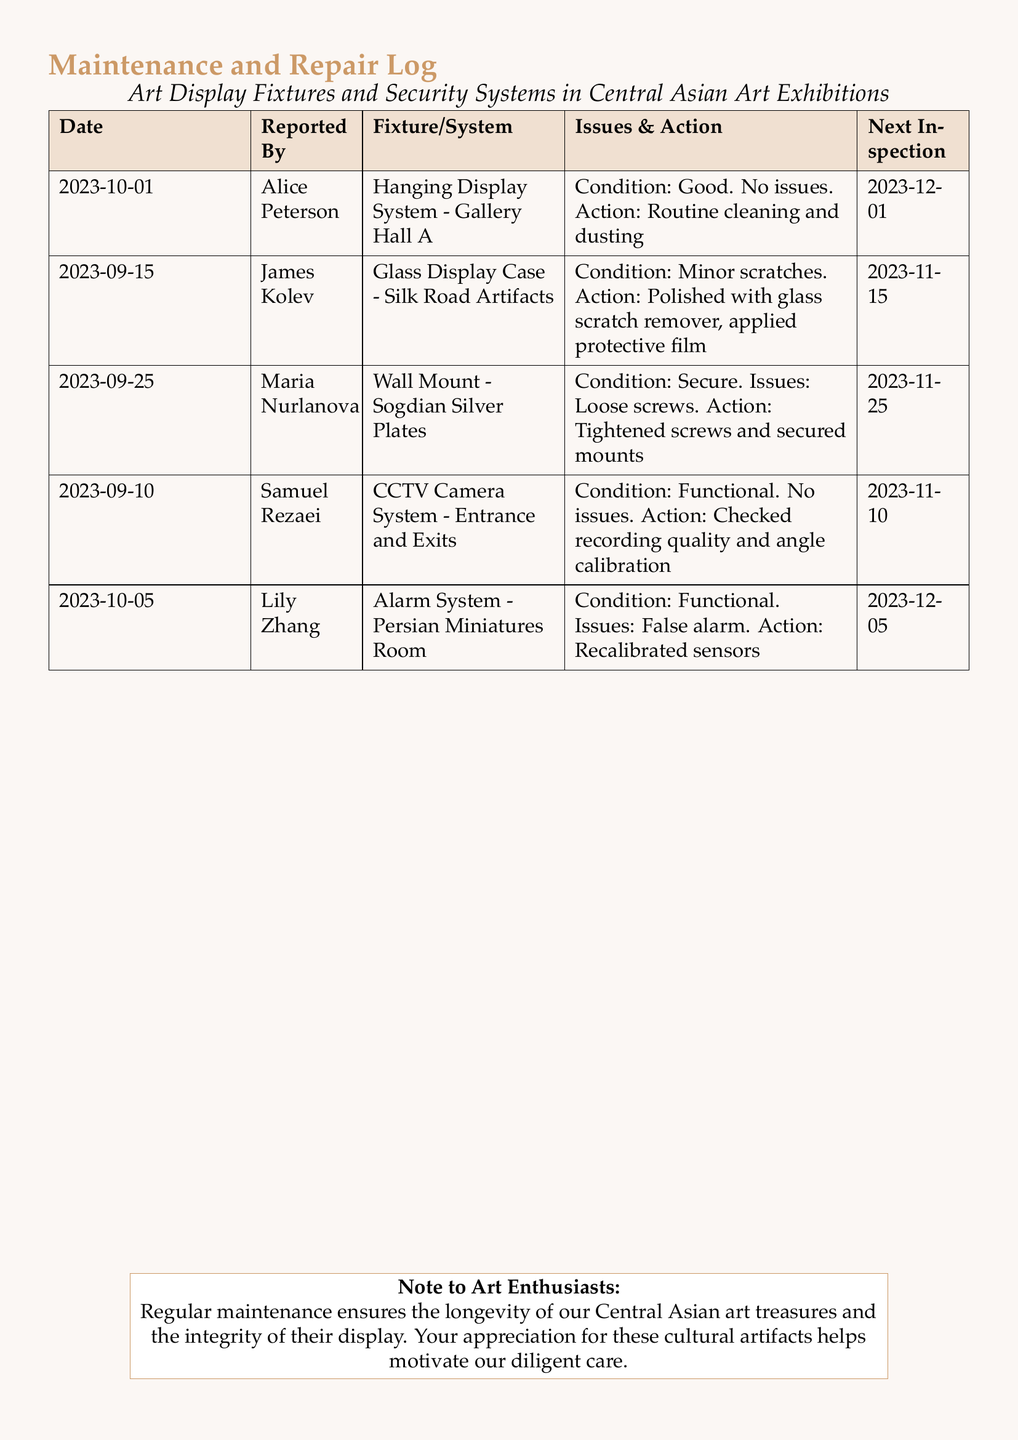What date was the hanging display system last inspected? The last inspection date for the hanging display system is mentioned in the log entry corresponding to it.
Answer: 2023-12-01 Who reported the issue with the glass display case? The name of the individual who reported the issue with the glass display case is listed in the document.
Answer: James Kolev What action was taken for the wall mount of Sogdian silver plates? The action taken for the wall mount is specified in the relevant entry, which discusses securing the mounts.
Answer: Tightened screws and secured mounts When is the next inspection for the alarm system? The next inspection date for the alarm system can be found in the log entry related to it.
Answer: 2023-12-05 How many fixtures have "No issues" stated in their condition? The log entries contain information on the conditions of various fixtures, and this can be totaled from the entries provided.
Answer: 2 What condition was the CCTV camera system reported to be in? The document specifies the condition of the CCTV camera system under the relevant section.
Answer: Functional Why was the alarm system recalibrated? The reason for recalibrating the alarm system is mentioned in the entry related to its inspection.
Answer: False alarm What is the color used for the heading of the maintenance log? The document specifies the color used for the headers in the maintenance log.
Answer: Central Asian What is the significance of the note to art enthusiasts at the end of the document? The note emphasizes the importance of regular maintenance from the perspective of caring for cultural artifacts.
Answer: Ensures longevity and integrity 